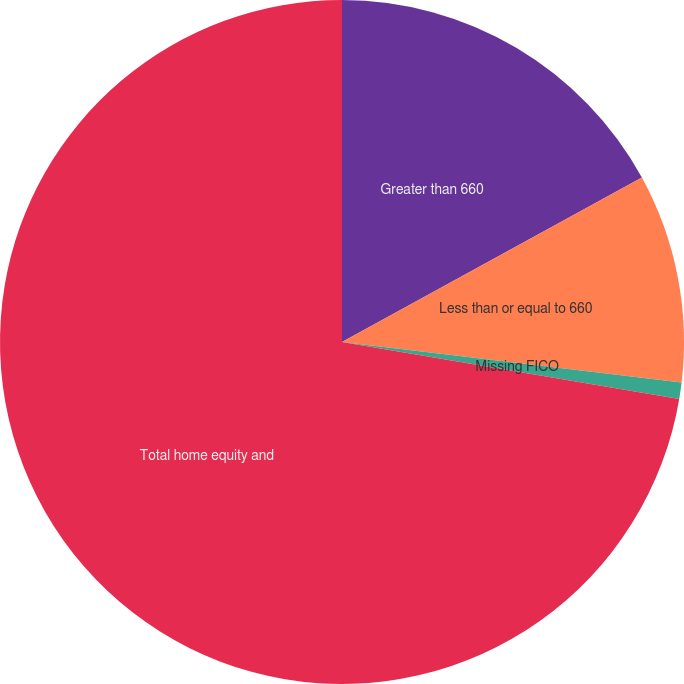<chart> <loc_0><loc_0><loc_500><loc_500><pie_chart><fcel>Greater than 660<fcel>Less than or equal to 660<fcel>Missing FICO<fcel>Total home equity and<nl><fcel>17.02%<fcel>9.87%<fcel>0.77%<fcel>72.34%<nl></chart> 